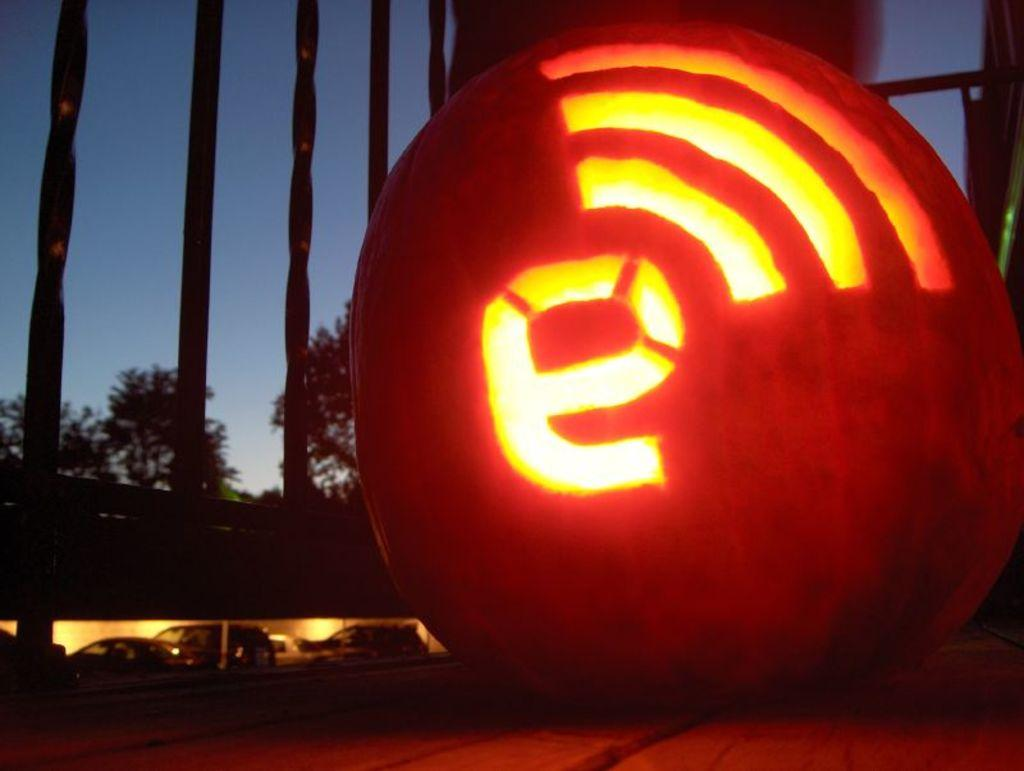What can be seen on the road in the image? There are vehicles on the road in the image. What type of structures are visible in the image? There are grilles visible in the image. What is the lighted object in the image? The lighted object in the image is not specified, but it could be a streetlight or a headlight. What type of natural elements can be seen in the image? There are trees in the image. Can you tell me how many veins are visible in the image? There are no veins present in the image; it features vehicles, grilles, a lighted object, and trees. What type of discovery is being made in the image? There is no discovery being made in the image; it is a scene of vehicles on the road, grilles, a lighted object, and trees. 